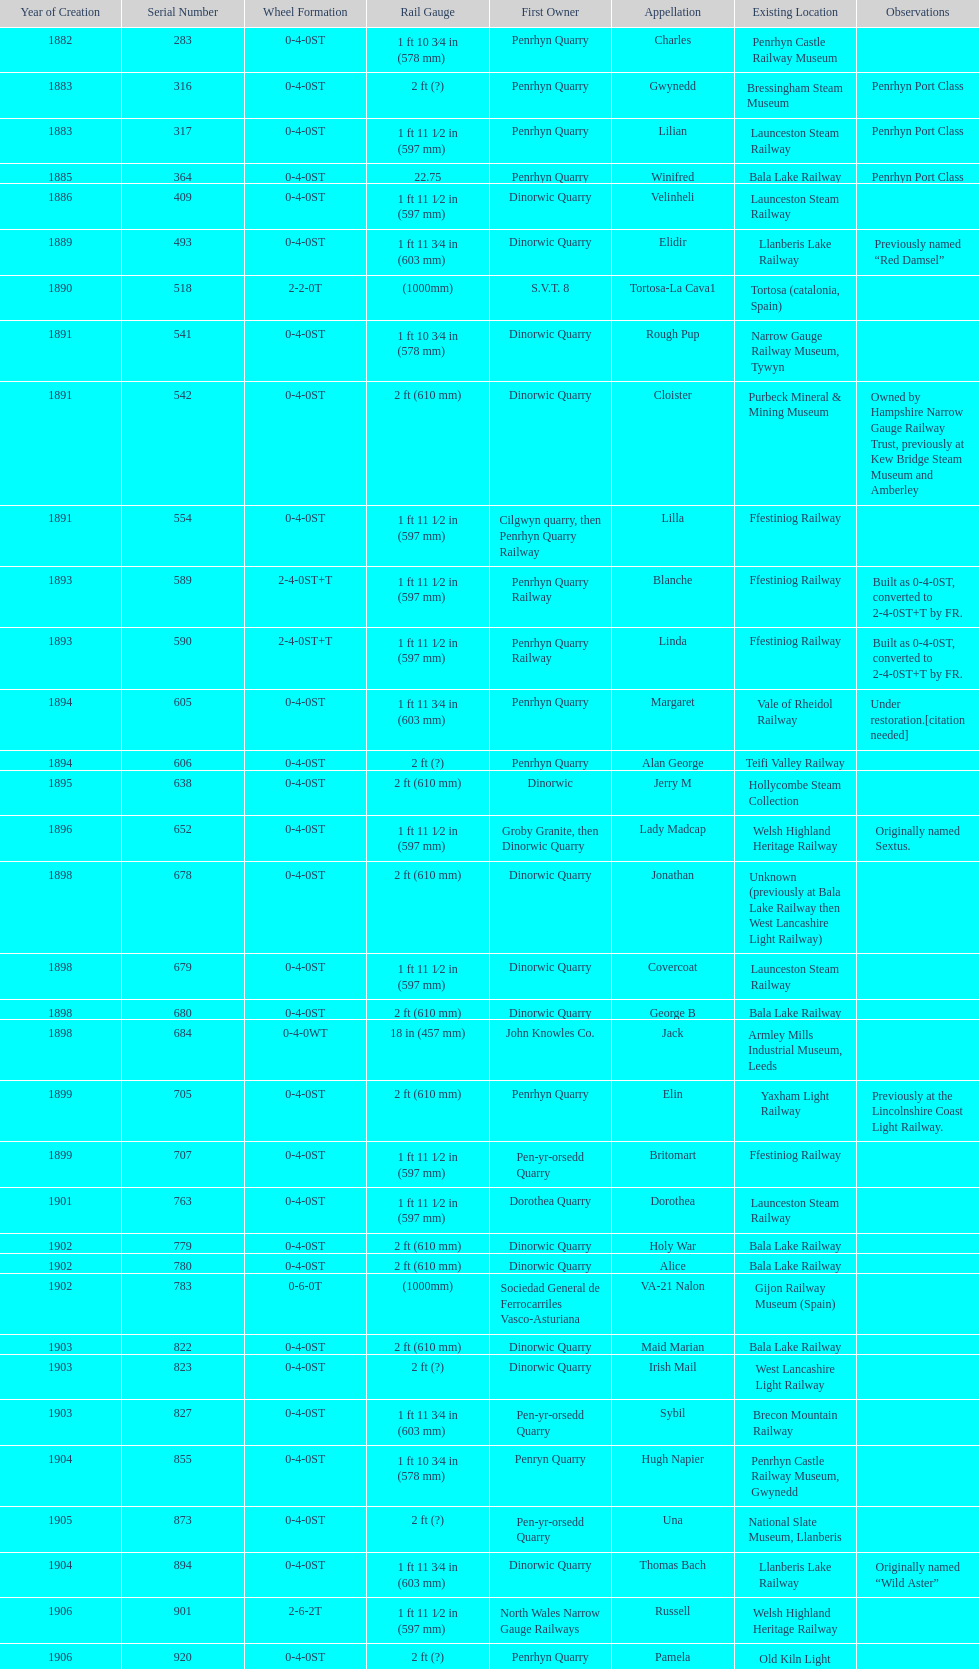Who owned the last locomotive to be built? Trangkil Sugar Mill, Indonesia. 